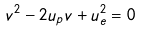Convert formula to latex. <formula><loc_0><loc_0><loc_500><loc_500>v ^ { 2 } - 2 u _ { p } v + u _ { e } ^ { 2 } = 0</formula> 